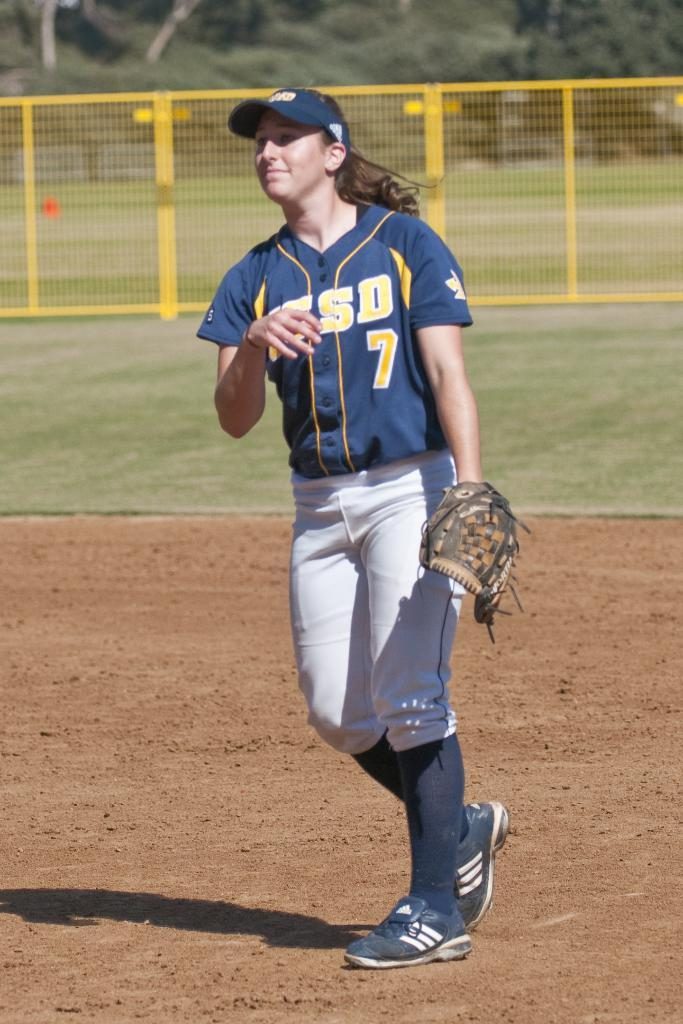<image>
Write a terse but informative summary of the picture. A UCSD softball player wearing the number 7 during a game. 